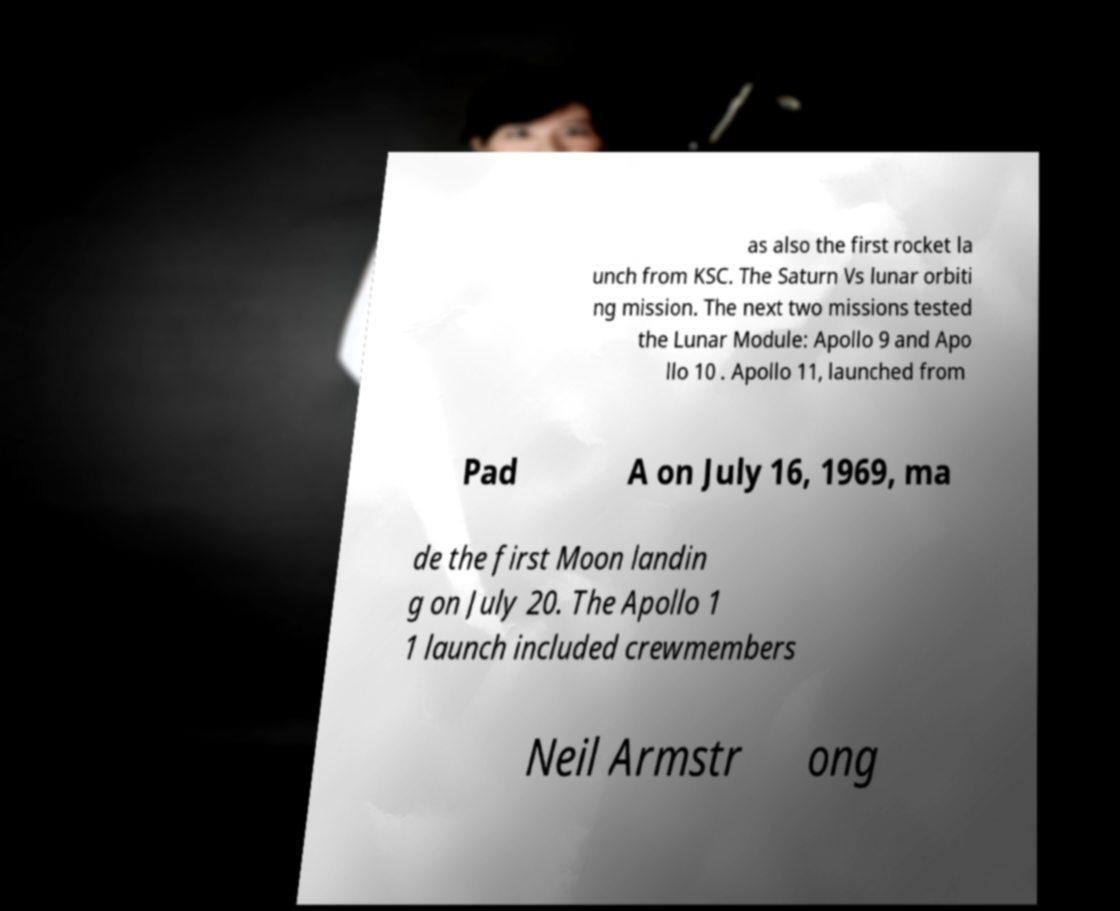There's text embedded in this image that I need extracted. Can you transcribe it verbatim? as also the first rocket la unch from KSC. The Saturn Vs lunar orbiti ng mission. The next two missions tested the Lunar Module: Apollo 9 and Apo llo 10 . Apollo 11, launched from Pad A on July 16, 1969, ma de the first Moon landin g on July 20. The Apollo 1 1 launch included crewmembers Neil Armstr ong 